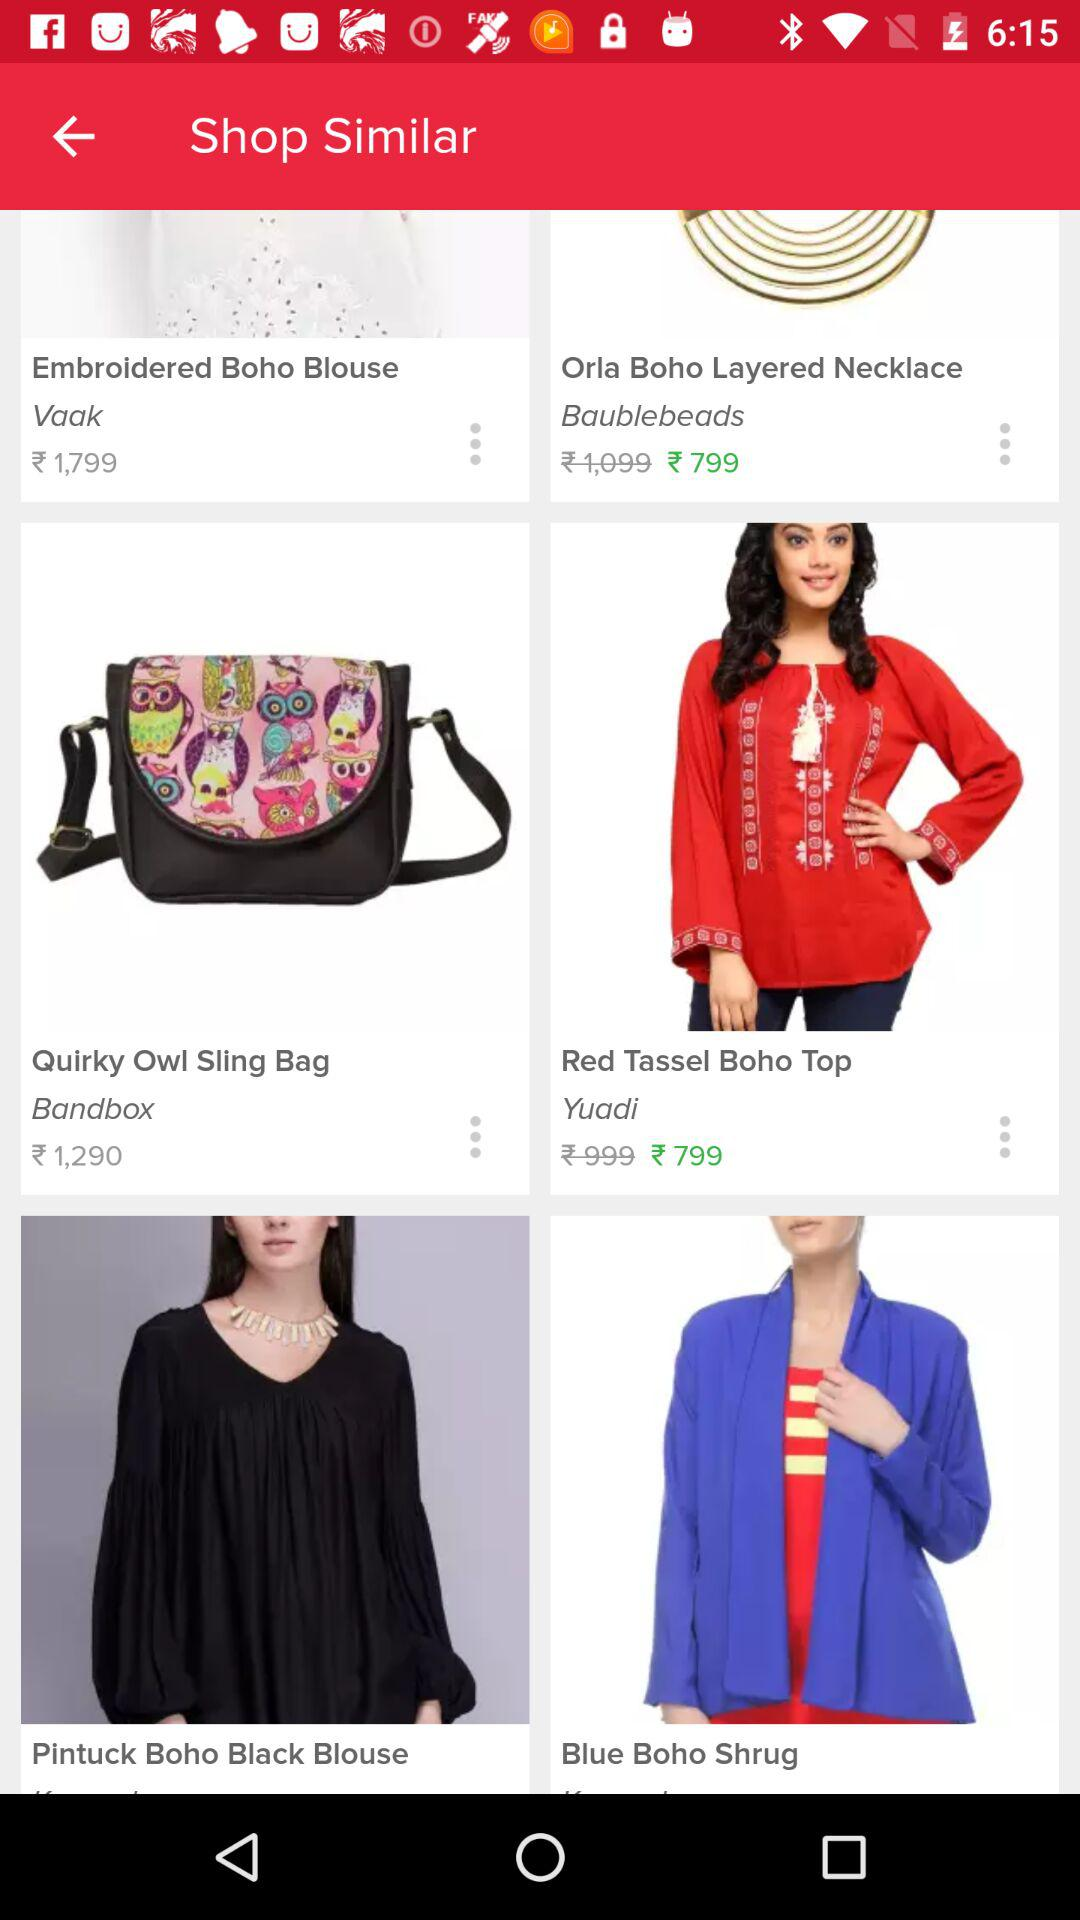What is the price for the "Quail Owl Sling Bag"? The price is ₹1,290. 